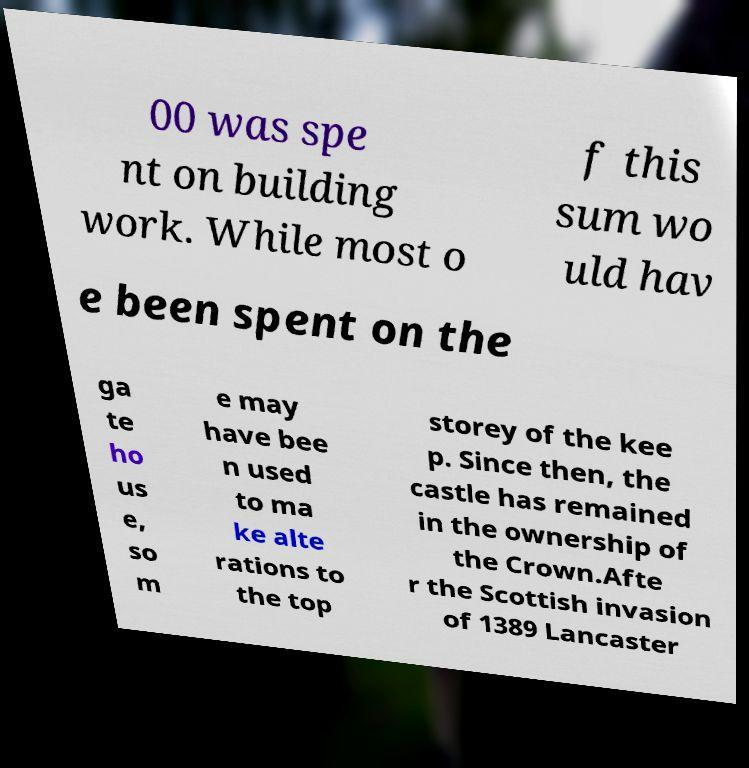I need the written content from this picture converted into text. Can you do that? 00 was spe nt on building work. While most o f this sum wo uld hav e been spent on the ga te ho us e, so m e may have bee n used to ma ke alte rations to the top storey of the kee p. Since then, the castle has remained in the ownership of the Crown.Afte r the Scottish invasion of 1389 Lancaster 